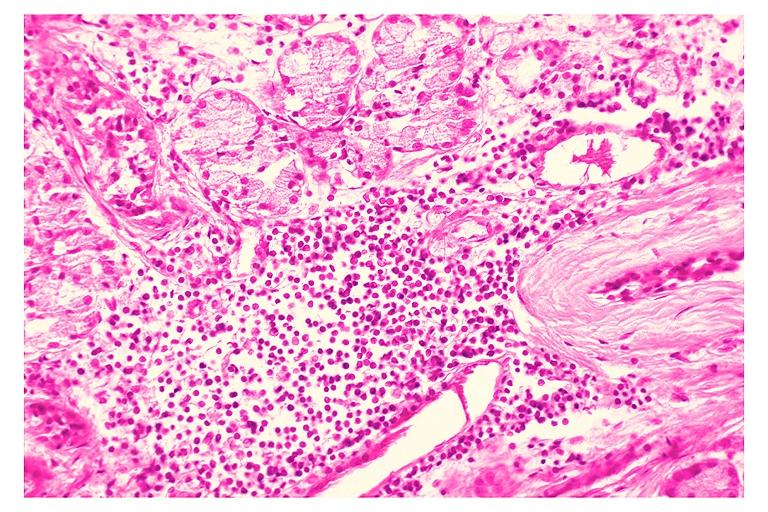what does this image show?
Answer the question using a single word or phrase. Chronic sialadenitis 